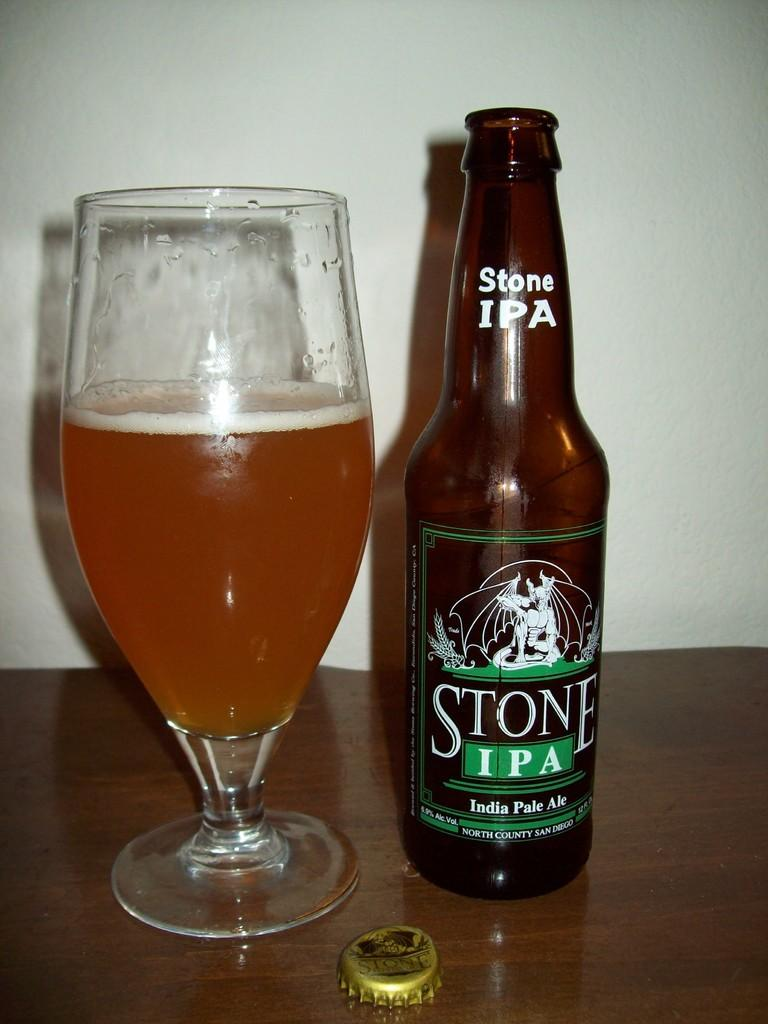<image>
Describe the image concisely. A bottle of Stone IPA beer that was poured into glass. 